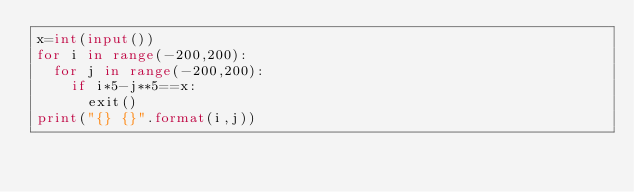<code> <loc_0><loc_0><loc_500><loc_500><_Python_>x=int(input())
for i in range(-200,200):
  for j in range(-200,200):
    if i*5-j**5==x:
      exit()
print("{} {}".format(i,j))</code> 